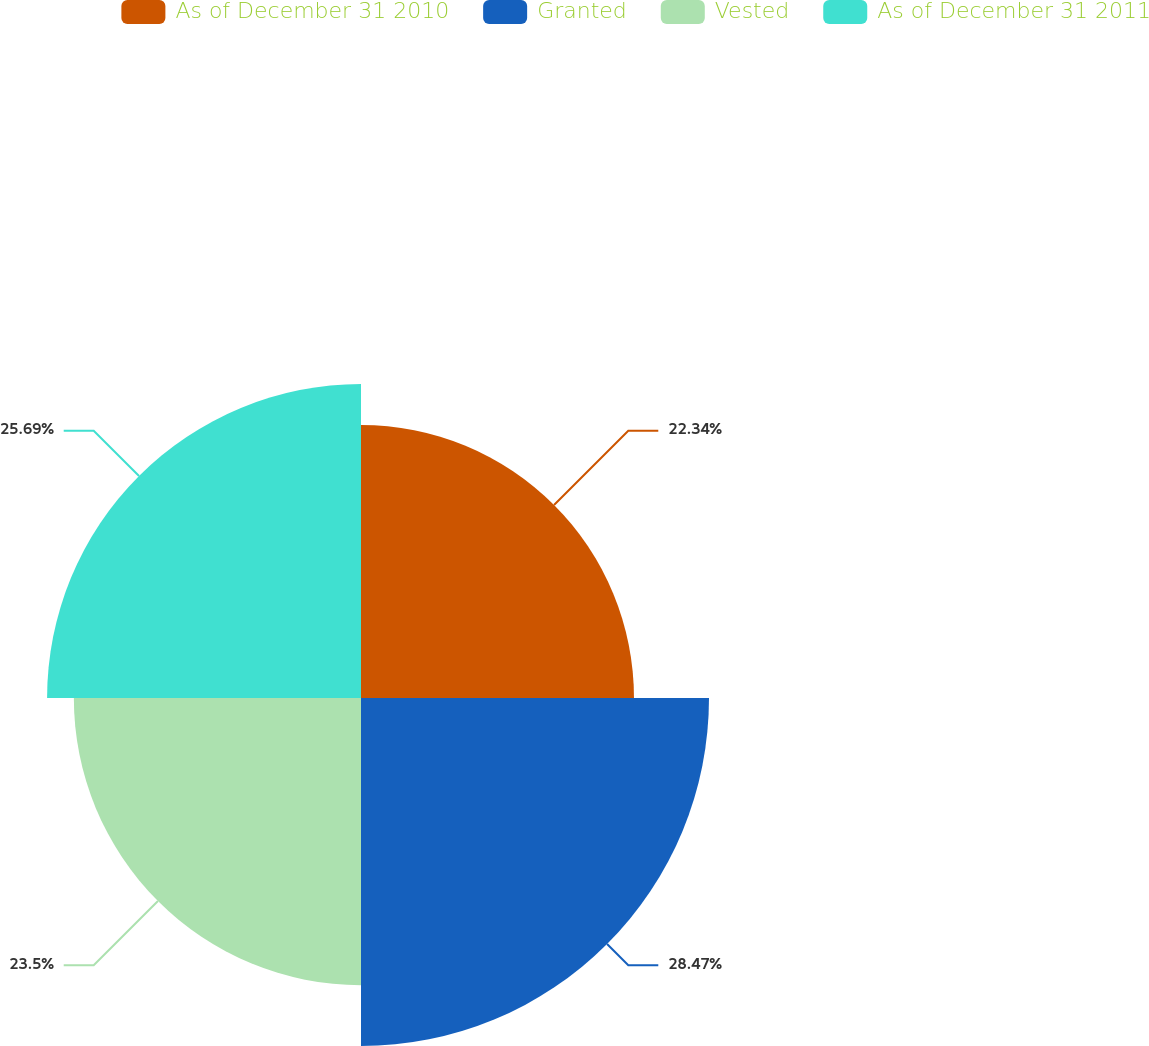Convert chart to OTSL. <chart><loc_0><loc_0><loc_500><loc_500><pie_chart><fcel>As of December 31 2010<fcel>Granted<fcel>Vested<fcel>As of December 31 2011<nl><fcel>22.34%<fcel>28.48%<fcel>23.5%<fcel>25.69%<nl></chart> 